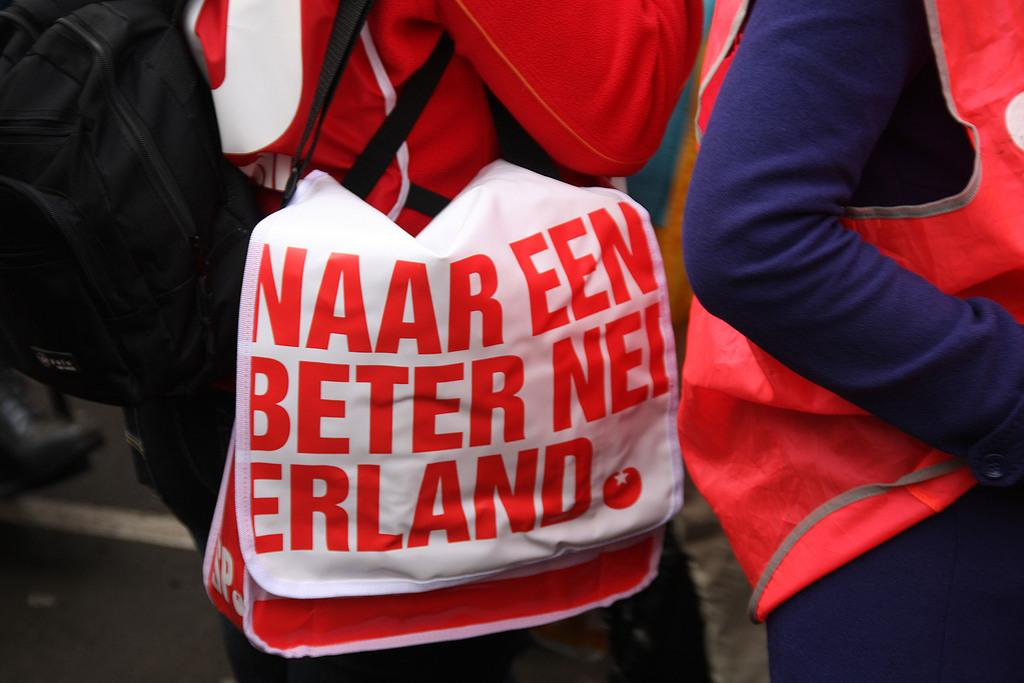<image>
Present a compact description of the photo's key features. a closeup of someone's red and white bag they're carrying saying NAAR EEN BETER NEIERLAND. 